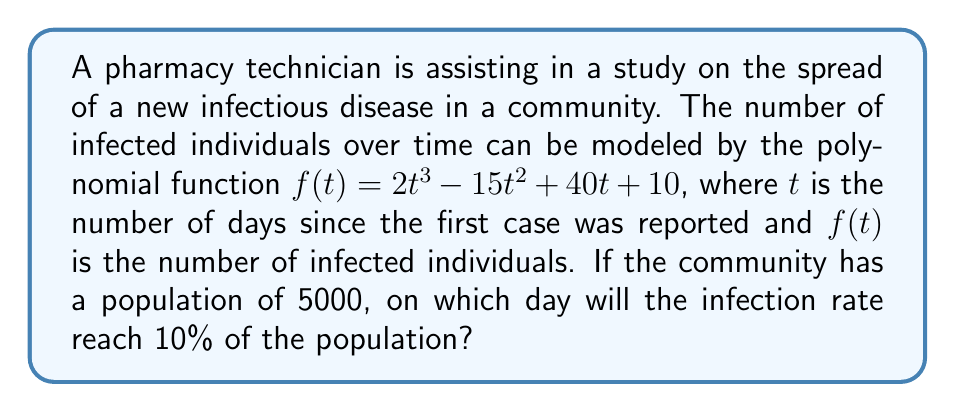Solve this math problem. To solve this problem, we need to follow these steps:

1) First, calculate 10% of the population:
   $10\% \text{ of } 5000 = 0.10 \times 5000 = 500$ individuals

2) Now, we need to find $t$ when $f(t) = 500$:
   $500 = 2t^3 - 15t^2 + 40t + 10$

3) Rearrange the equation:
   $2t^3 - 15t^2 + 40t - 490 = 0$

4) This is a cubic equation. It's difficult to solve by factoring, so we'll use the rational root theorem. The possible rational roots are the factors of the constant term (490):
   $\pm 1, \pm 2, \pm 5, \pm 7, \pm 10, \pm 14, \pm 35, \pm 49, \pm 70, \pm 98, \pm 245, \pm 490$

5) Testing these values, we find that $t = 7$ satisfies the equation:
   $2(7^3) - 15(7^2) + 40(7) - 490 = 686 - 735 + 280 - 490 = -259 + 259 = 0$

6) Therefore, the infection rate will reach 10% of the population on day 7.
Answer: 7 days 